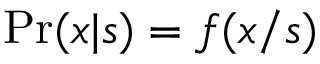Convert formula to latex. <formula><loc_0><loc_0><loc_500><loc_500>P r ( x | s ) = f ( x / s )</formula> 